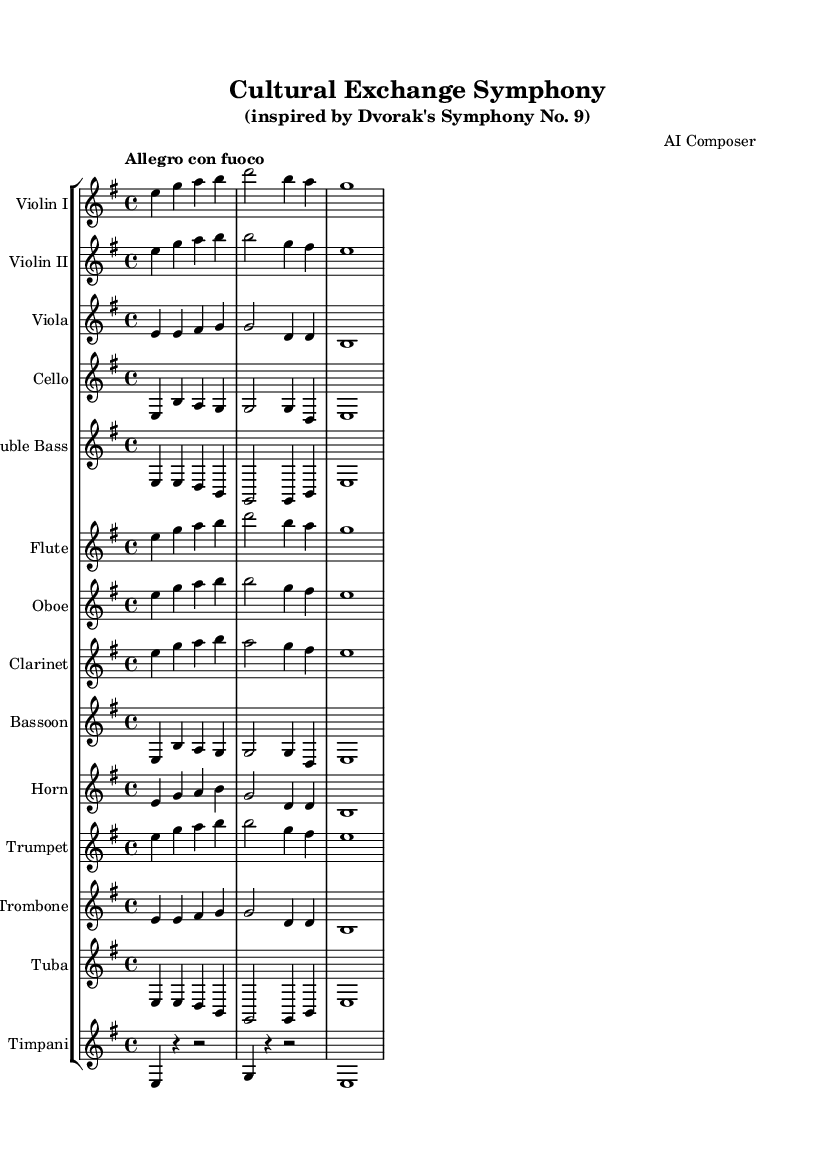What is the key signature of this music? The key signature is E minor, which has one sharp (F sharp) in the key signature. It can be identified at the beginning of the staff where the sharps are marked.
Answer: E minor What is the time signature of this music? The time signature is 4/4, indicated at the beginning of the score where the time symbol is placed. It means there are four beats in each measure and the quarter note gets one beat.
Answer: 4/4 What is the tempo marking for this symphony? The tempo marking is "Allegro con fuoco", indicated at the beginning of the piece. This means to play lively and with fire or passion.
Answer: Allegro con fuoco How many instruments are featured in this symphony? The score includes a total of 13 instruments, which is evidenced by the individual staves for each instrument listed in the staff group.
Answer: 13 Which instrument plays the melody in the first few measures? The melody is primarily played by the Violins (I and II), as they have prominent and leading notes during the introductory measures of the piece.
Answer: Violins What is the role of the timpani in this symphony? The timpani provide rhythmic support and accentuate the dynamic shifts throughout the score. In the provided measures, they execute measures with rests and strong hits, underscoring key transitions.
Answer: Rhythmic support What dynamic markings are used in this symphony? The dynamic markings appear to be implicit in the scoring and can be interpreted based on the context of the notes played. There are no explicit dynamics notated, indicating a more flexible interpretation left to the performers.
Answer: Implicit dynamics 